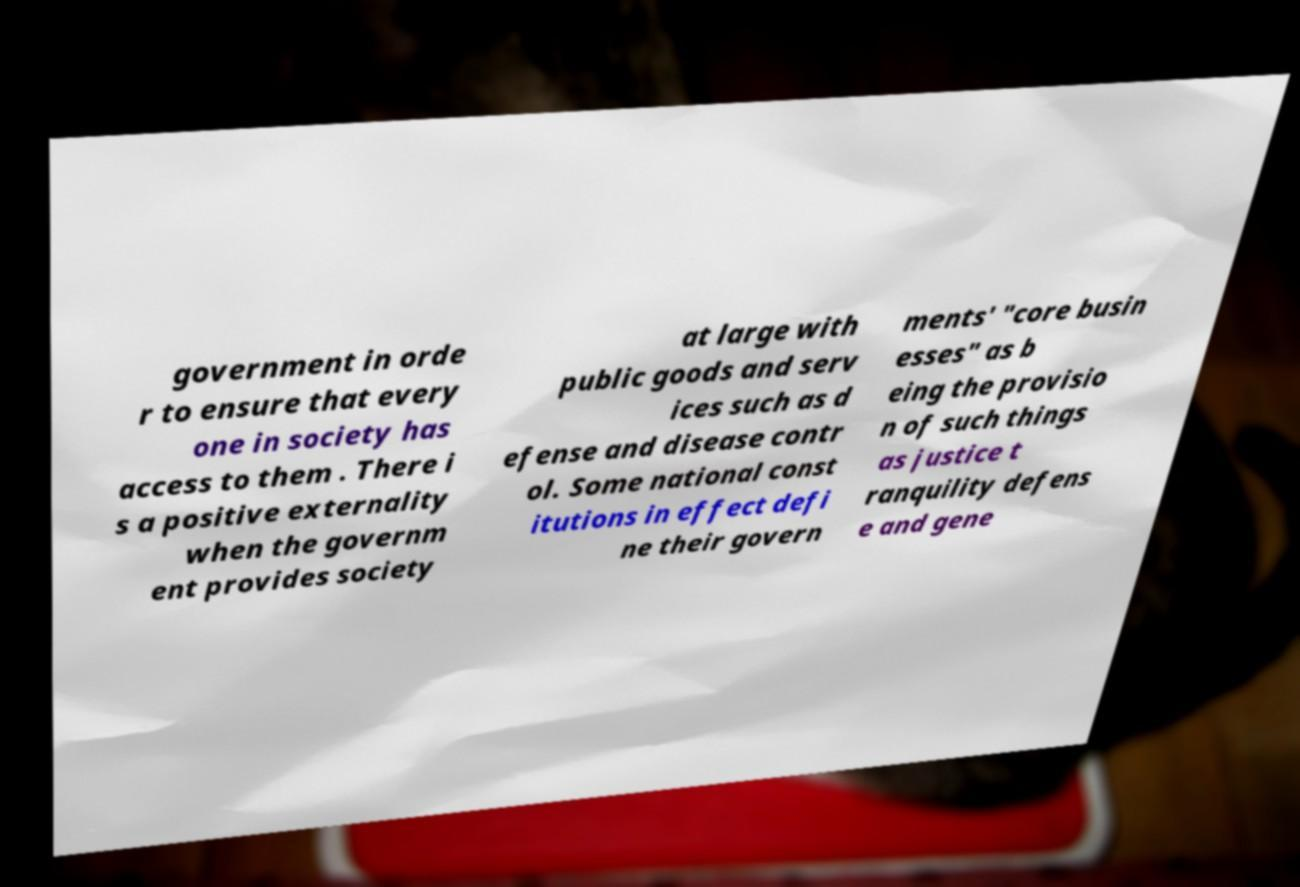Can you accurately transcribe the text from the provided image for me? government in orde r to ensure that every one in society has access to them . There i s a positive externality when the governm ent provides society at large with public goods and serv ices such as d efense and disease contr ol. Some national const itutions in effect defi ne their govern ments' "core busin esses" as b eing the provisio n of such things as justice t ranquility defens e and gene 